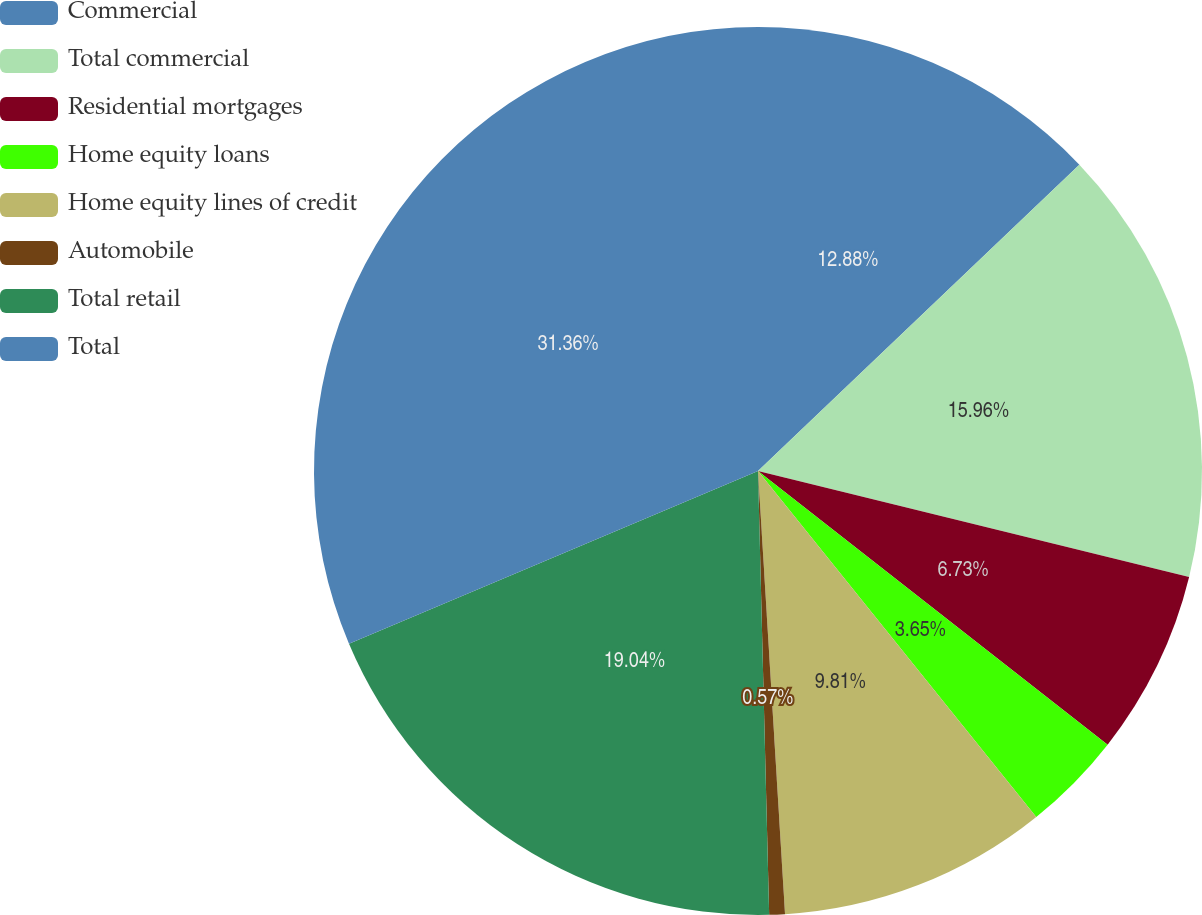Convert chart to OTSL. <chart><loc_0><loc_0><loc_500><loc_500><pie_chart><fcel>Commercial<fcel>Total commercial<fcel>Residential mortgages<fcel>Home equity loans<fcel>Home equity lines of credit<fcel>Automobile<fcel>Total retail<fcel>Total<nl><fcel>12.88%<fcel>15.96%<fcel>6.73%<fcel>3.65%<fcel>9.81%<fcel>0.57%<fcel>19.04%<fcel>31.36%<nl></chart> 